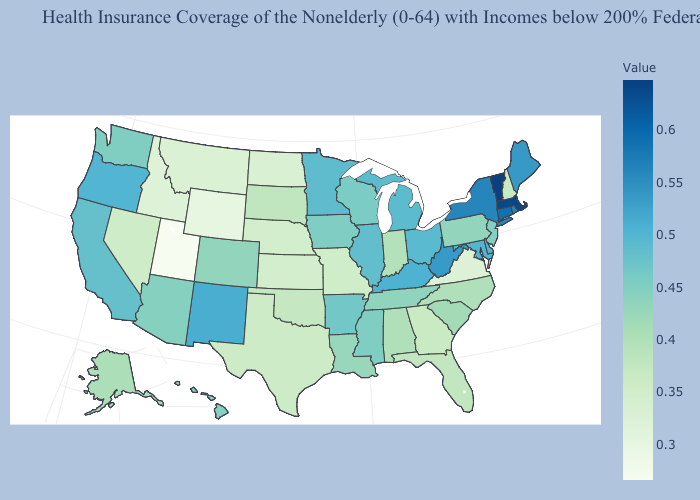Among the states that border Minnesota , does Wisconsin have the highest value?
Quick response, please. Yes. Does Utah have the lowest value in the USA?
Answer briefly. Yes. Does Alabama have a higher value than Michigan?
Be succinct. No. Does New Jersey have the lowest value in the Northeast?
Give a very brief answer. No. Among the states that border Colorado , does Kansas have the lowest value?
Short answer required. No. Which states have the lowest value in the USA?
Be succinct. Utah. Among the states that border California , does Oregon have the lowest value?
Answer briefly. No. 